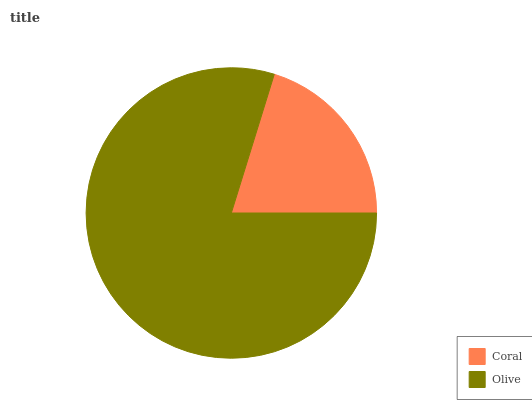Is Coral the minimum?
Answer yes or no. Yes. Is Olive the maximum?
Answer yes or no. Yes. Is Olive the minimum?
Answer yes or no. No. Is Olive greater than Coral?
Answer yes or no. Yes. Is Coral less than Olive?
Answer yes or no. Yes. Is Coral greater than Olive?
Answer yes or no. No. Is Olive less than Coral?
Answer yes or no. No. Is Olive the high median?
Answer yes or no. Yes. Is Coral the low median?
Answer yes or no. Yes. Is Coral the high median?
Answer yes or no. No. Is Olive the low median?
Answer yes or no. No. 